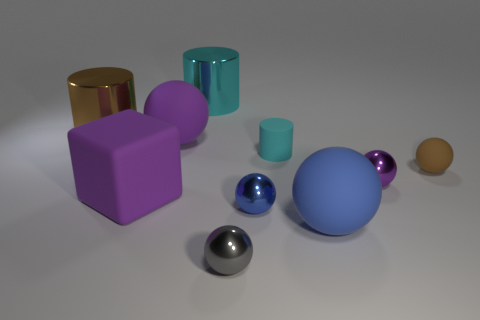There is a tiny sphere that is on the right side of the tiny purple thing; what color is it?
Provide a short and direct response. Brown. What shape is the tiny gray thing?
Ensure brevity in your answer.  Sphere. There is a big sphere in front of the object that is right of the tiny purple thing; are there any matte spheres that are in front of it?
Your response must be concise. No. The cylinder on the right side of the cyan object behind the purple sphere on the left side of the tiny purple metallic thing is what color?
Your answer should be very brief. Cyan. What is the material of the small blue thing that is the same shape as the brown rubber object?
Your response must be concise. Metal. What size is the cyan cylinder to the right of the large metallic cylinder on the right side of the big brown thing?
Give a very brief answer. Small. What is the material of the brown object that is behind the brown rubber object?
Your answer should be very brief. Metal. There is a purple sphere that is the same material as the gray sphere; what is its size?
Give a very brief answer. Small. How many tiny matte things are the same shape as the purple shiny object?
Offer a terse response. 1. There is a blue metal object; is its shape the same as the cyan object that is on the right side of the small gray thing?
Ensure brevity in your answer.  No. 